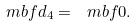Convert formula to latex. <formula><loc_0><loc_0><loc_500><loc_500>\ m b f { d } _ { 4 } = \ m b f { 0 } .</formula> 